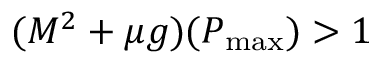<formula> <loc_0><loc_0><loc_500><loc_500>( M ^ { 2 } + \mu g ) ( P _ { \max } ) > 1</formula> 